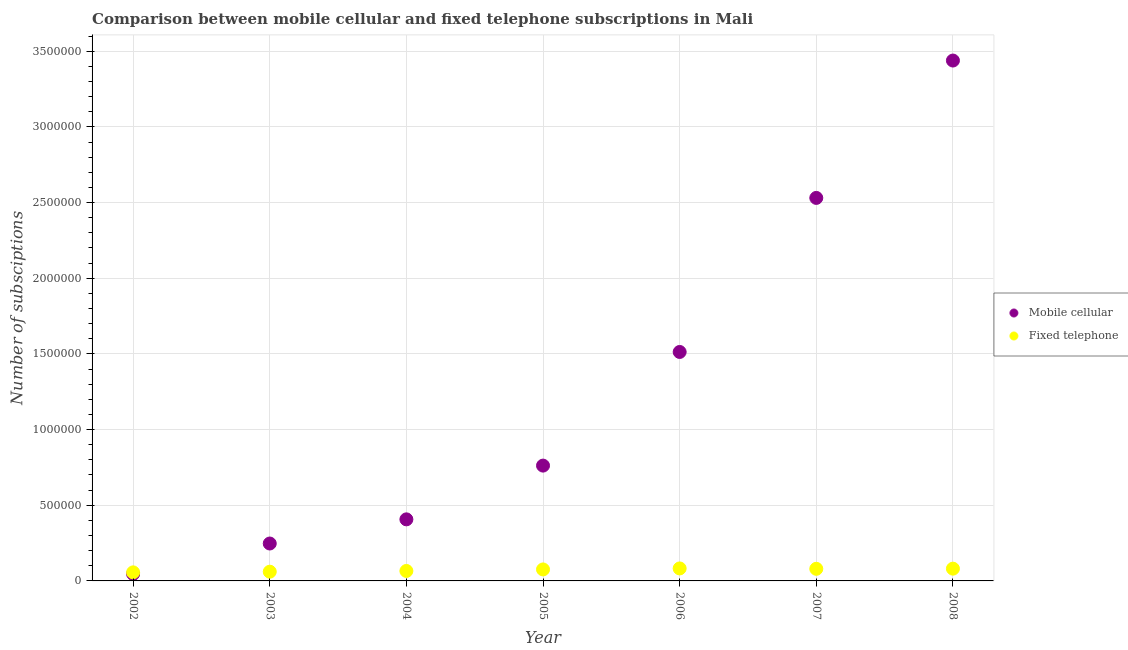How many different coloured dotlines are there?
Provide a succinct answer. 2. What is the number of mobile cellular subscriptions in 2006?
Give a very brief answer. 1.51e+06. Across all years, what is the maximum number of mobile cellular subscriptions?
Give a very brief answer. 3.44e+06. Across all years, what is the minimum number of fixed telephone subscriptions?
Give a very brief answer. 5.66e+04. In which year was the number of mobile cellular subscriptions maximum?
Offer a very short reply. 2008. In which year was the number of mobile cellular subscriptions minimum?
Give a very brief answer. 2002. What is the total number of fixed telephone subscriptions in the graph?
Keep it short and to the point. 5.03e+05. What is the difference between the number of fixed telephone subscriptions in 2004 and that in 2007?
Ensure brevity in your answer.  -1.42e+04. What is the difference between the number of fixed telephone subscriptions in 2003 and the number of mobile cellular subscriptions in 2007?
Offer a terse response. -2.47e+06. What is the average number of fixed telephone subscriptions per year?
Provide a succinct answer. 7.18e+04. In the year 2006, what is the difference between the number of fixed telephone subscriptions and number of mobile cellular subscriptions?
Your answer should be compact. -1.43e+06. What is the ratio of the number of mobile cellular subscriptions in 2004 to that in 2006?
Provide a short and direct response. 0.27. Is the difference between the number of fixed telephone subscriptions in 2005 and 2008 greater than the difference between the number of mobile cellular subscriptions in 2005 and 2008?
Provide a succinct answer. Yes. What is the difference between the highest and the second highest number of mobile cellular subscriptions?
Offer a terse response. 9.08e+05. What is the difference between the highest and the lowest number of mobile cellular subscriptions?
Keep it short and to the point. 3.39e+06. In how many years, is the number of mobile cellular subscriptions greater than the average number of mobile cellular subscriptions taken over all years?
Give a very brief answer. 3. Is the sum of the number of mobile cellular subscriptions in 2004 and 2008 greater than the maximum number of fixed telephone subscriptions across all years?
Ensure brevity in your answer.  Yes. Is the number of fixed telephone subscriptions strictly less than the number of mobile cellular subscriptions over the years?
Make the answer very short. No. How many dotlines are there?
Your answer should be very brief. 2. Are the values on the major ticks of Y-axis written in scientific E-notation?
Provide a short and direct response. No. How many legend labels are there?
Provide a short and direct response. 2. How are the legend labels stacked?
Offer a very short reply. Vertical. What is the title of the graph?
Ensure brevity in your answer.  Comparison between mobile cellular and fixed telephone subscriptions in Mali. What is the label or title of the Y-axis?
Keep it short and to the point. Number of subsciptions. What is the Number of subsciptions of Mobile cellular in 2002?
Provide a succinct answer. 4.60e+04. What is the Number of subsciptions of Fixed telephone in 2002?
Your answer should be compact. 5.66e+04. What is the Number of subsciptions of Mobile cellular in 2003?
Offer a very short reply. 2.47e+05. What is the Number of subsciptions in Fixed telephone in 2003?
Offer a very short reply. 6.09e+04. What is the Number of subsciptions of Mobile cellular in 2004?
Give a very brief answer. 4.07e+05. What is the Number of subsciptions in Fixed telephone in 2004?
Offer a very short reply. 6.58e+04. What is the Number of subsciptions of Mobile cellular in 2005?
Offer a terse response. 7.62e+05. What is the Number of subsciptions in Fixed telephone in 2005?
Your answer should be compact. 7.59e+04. What is the Number of subsciptions in Mobile cellular in 2006?
Make the answer very short. 1.51e+06. What is the Number of subsciptions in Fixed telephone in 2006?
Give a very brief answer. 8.25e+04. What is the Number of subsciptions of Mobile cellular in 2007?
Provide a short and direct response. 2.53e+06. What is the Number of subsciptions in Fixed telephone in 2007?
Your answer should be very brief. 8.00e+04. What is the Number of subsciptions of Mobile cellular in 2008?
Provide a short and direct response. 3.44e+06. What is the Number of subsciptions of Fixed telephone in 2008?
Provide a succinct answer. 8.11e+04. Across all years, what is the maximum Number of subsciptions of Mobile cellular?
Provide a short and direct response. 3.44e+06. Across all years, what is the maximum Number of subsciptions of Fixed telephone?
Offer a very short reply. 8.25e+04. Across all years, what is the minimum Number of subsciptions in Mobile cellular?
Provide a succinct answer. 4.60e+04. Across all years, what is the minimum Number of subsciptions in Fixed telephone?
Offer a terse response. 5.66e+04. What is the total Number of subsciptions of Mobile cellular in the graph?
Offer a terse response. 8.94e+06. What is the total Number of subsciptions in Fixed telephone in the graph?
Your response must be concise. 5.03e+05. What is the difference between the Number of subsciptions in Mobile cellular in 2002 and that in 2003?
Give a very brief answer. -2.01e+05. What is the difference between the Number of subsciptions in Fixed telephone in 2002 and that in 2003?
Offer a very short reply. -4322. What is the difference between the Number of subsciptions in Mobile cellular in 2002 and that in 2004?
Keep it short and to the point. -3.61e+05. What is the difference between the Number of subsciptions in Fixed telephone in 2002 and that in 2004?
Offer a terse response. -9231. What is the difference between the Number of subsciptions of Mobile cellular in 2002 and that in 2005?
Keep it short and to the point. -7.16e+05. What is the difference between the Number of subsciptions in Fixed telephone in 2002 and that in 2005?
Provide a short and direct response. -1.93e+04. What is the difference between the Number of subsciptions of Mobile cellular in 2002 and that in 2006?
Offer a terse response. -1.47e+06. What is the difference between the Number of subsciptions of Fixed telephone in 2002 and that in 2006?
Provide a succinct answer. -2.59e+04. What is the difference between the Number of subsciptions of Mobile cellular in 2002 and that in 2007?
Your answer should be very brief. -2.48e+06. What is the difference between the Number of subsciptions in Fixed telephone in 2002 and that in 2007?
Provide a short and direct response. -2.34e+04. What is the difference between the Number of subsciptions of Mobile cellular in 2002 and that in 2008?
Your response must be concise. -3.39e+06. What is the difference between the Number of subsciptions of Fixed telephone in 2002 and that in 2008?
Provide a succinct answer. -2.45e+04. What is the difference between the Number of subsciptions of Mobile cellular in 2003 and that in 2004?
Your response must be concise. -1.60e+05. What is the difference between the Number of subsciptions in Fixed telephone in 2003 and that in 2004?
Offer a very short reply. -4909. What is the difference between the Number of subsciptions of Mobile cellular in 2003 and that in 2005?
Your answer should be compact. -5.15e+05. What is the difference between the Number of subsciptions in Fixed telephone in 2003 and that in 2005?
Provide a succinct answer. -1.50e+04. What is the difference between the Number of subsciptions of Mobile cellular in 2003 and that in 2006?
Give a very brief answer. -1.27e+06. What is the difference between the Number of subsciptions of Fixed telephone in 2003 and that in 2006?
Make the answer very short. -2.16e+04. What is the difference between the Number of subsciptions in Mobile cellular in 2003 and that in 2007?
Offer a very short reply. -2.28e+06. What is the difference between the Number of subsciptions in Fixed telephone in 2003 and that in 2007?
Offer a terse response. -1.91e+04. What is the difference between the Number of subsciptions of Mobile cellular in 2003 and that in 2008?
Provide a succinct answer. -3.19e+06. What is the difference between the Number of subsciptions in Fixed telephone in 2003 and that in 2008?
Ensure brevity in your answer.  -2.02e+04. What is the difference between the Number of subsciptions in Mobile cellular in 2004 and that in 2005?
Give a very brief answer. -3.55e+05. What is the difference between the Number of subsciptions in Fixed telephone in 2004 and that in 2005?
Your answer should be very brief. -1.01e+04. What is the difference between the Number of subsciptions of Mobile cellular in 2004 and that in 2006?
Give a very brief answer. -1.11e+06. What is the difference between the Number of subsciptions of Fixed telephone in 2004 and that in 2006?
Your response must be concise. -1.67e+04. What is the difference between the Number of subsciptions of Mobile cellular in 2004 and that in 2007?
Your response must be concise. -2.12e+06. What is the difference between the Number of subsciptions of Fixed telephone in 2004 and that in 2007?
Keep it short and to the point. -1.42e+04. What is the difference between the Number of subsciptions in Mobile cellular in 2004 and that in 2008?
Keep it short and to the point. -3.03e+06. What is the difference between the Number of subsciptions of Fixed telephone in 2004 and that in 2008?
Offer a very short reply. -1.52e+04. What is the difference between the Number of subsciptions in Mobile cellular in 2005 and that in 2006?
Your answer should be very brief. -7.51e+05. What is the difference between the Number of subsciptions of Fixed telephone in 2005 and that in 2006?
Provide a short and direct response. -6617. What is the difference between the Number of subsciptions of Mobile cellular in 2005 and that in 2007?
Provide a succinct answer. -1.77e+06. What is the difference between the Number of subsciptions in Fixed telephone in 2005 and that in 2007?
Your answer should be very brief. -4101. What is the difference between the Number of subsciptions of Mobile cellular in 2005 and that in 2008?
Your response must be concise. -2.68e+06. What is the difference between the Number of subsciptions of Fixed telephone in 2005 and that in 2008?
Your answer should be very brief. -5172. What is the difference between the Number of subsciptions of Mobile cellular in 2006 and that in 2007?
Your answer should be very brief. -1.02e+06. What is the difference between the Number of subsciptions of Fixed telephone in 2006 and that in 2007?
Offer a very short reply. 2516. What is the difference between the Number of subsciptions of Mobile cellular in 2006 and that in 2008?
Keep it short and to the point. -1.93e+06. What is the difference between the Number of subsciptions of Fixed telephone in 2006 and that in 2008?
Your answer should be very brief. 1445. What is the difference between the Number of subsciptions in Mobile cellular in 2007 and that in 2008?
Ensure brevity in your answer.  -9.08e+05. What is the difference between the Number of subsciptions of Fixed telephone in 2007 and that in 2008?
Provide a short and direct response. -1071. What is the difference between the Number of subsciptions of Mobile cellular in 2002 and the Number of subsciptions of Fixed telephone in 2003?
Give a very brief answer. -1.50e+04. What is the difference between the Number of subsciptions of Mobile cellular in 2002 and the Number of subsciptions of Fixed telephone in 2004?
Your response must be concise. -1.99e+04. What is the difference between the Number of subsciptions of Mobile cellular in 2002 and the Number of subsciptions of Fixed telephone in 2005?
Ensure brevity in your answer.  -2.99e+04. What is the difference between the Number of subsciptions in Mobile cellular in 2002 and the Number of subsciptions in Fixed telephone in 2006?
Give a very brief answer. -3.65e+04. What is the difference between the Number of subsciptions of Mobile cellular in 2002 and the Number of subsciptions of Fixed telephone in 2007?
Offer a very short reply. -3.40e+04. What is the difference between the Number of subsciptions in Mobile cellular in 2002 and the Number of subsciptions in Fixed telephone in 2008?
Your answer should be compact. -3.51e+04. What is the difference between the Number of subsciptions in Mobile cellular in 2003 and the Number of subsciptions in Fixed telephone in 2004?
Make the answer very short. 1.81e+05. What is the difference between the Number of subsciptions of Mobile cellular in 2003 and the Number of subsciptions of Fixed telephone in 2005?
Your answer should be compact. 1.71e+05. What is the difference between the Number of subsciptions of Mobile cellular in 2003 and the Number of subsciptions of Fixed telephone in 2006?
Provide a succinct answer. 1.65e+05. What is the difference between the Number of subsciptions in Mobile cellular in 2003 and the Number of subsciptions in Fixed telephone in 2007?
Give a very brief answer. 1.67e+05. What is the difference between the Number of subsciptions of Mobile cellular in 2003 and the Number of subsciptions of Fixed telephone in 2008?
Your response must be concise. 1.66e+05. What is the difference between the Number of subsciptions of Mobile cellular in 2004 and the Number of subsciptions of Fixed telephone in 2005?
Offer a very short reply. 3.31e+05. What is the difference between the Number of subsciptions in Mobile cellular in 2004 and the Number of subsciptions in Fixed telephone in 2006?
Keep it short and to the point. 3.24e+05. What is the difference between the Number of subsciptions of Mobile cellular in 2004 and the Number of subsciptions of Fixed telephone in 2007?
Provide a short and direct response. 3.27e+05. What is the difference between the Number of subsciptions in Mobile cellular in 2004 and the Number of subsciptions in Fixed telephone in 2008?
Offer a very short reply. 3.26e+05. What is the difference between the Number of subsciptions in Mobile cellular in 2005 and the Number of subsciptions in Fixed telephone in 2006?
Give a very brief answer. 6.79e+05. What is the difference between the Number of subsciptions of Mobile cellular in 2005 and the Number of subsciptions of Fixed telephone in 2007?
Offer a very short reply. 6.82e+05. What is the difference between the Number of subsciptions of Mobile cellular in 2005 and the Number of subsciptions of Fixed telephone in 2008?
Make the answer very short. 6.81e+05. What is the difference between the Number of subsciptions in Mobile cellular in 2006 and the Number of subsciptions in Fixed telephone in 2007?
Your answer should be compact. 1.43e+06. What is the difference between the Number of subsciptions of Mobile cellular in 2006 and the Number of subsciptions of Fixed telephone in 2008?
Offer a terse response. 1.43e+06. What is the difference between the Number of subsciptions in Mobile cellular in 2007 and the Number of subsciptions in Fixed telephone in 2008?
Give a very brief answer. 2.45e+06. What is the average Number of subsciptions of Mobile cellular per year?
Offer a very short reply. 1.28e+06. What is the average Number of subsciptions of Fixed telephone per year?
Offer a terse response. 7.18e+04. In the year 2002, what is the difference between the Number of subsciptions of Mobile cellular and Number of subsciptions of Fixed telephone?
Ensure brevity in your answer.  -1.06e+04. In the year 2003, what is the difference between the Number of subsciptions of Mobile cellular and Number of subsciptions of Fixed telephone?
Make the answer very short. 1.86e+05. In the year 2004, what is the difference between the Number of subsciptions in Mobile cellular and Number of subsciptions in Fixed telephone?
Offer a very short reply. 3.41e+05. In the year 2005, what is the difference between the Number of subsciptions in Mobile cellular and Number of subsciptions in Fixed telephone?
Offer a very short reply. 6.86e+05. In the year 2006, what is the difference between the Number of subsciptions in Mobile cellular and Number of subsciptions in Fixed telephone?
Keep it short and to the point. 1.43e+06. In the year 2007, what is the difference between the Number of subsciptions of Mobile cellular and Number of subsciptions of Fixed telephone?
Provide a succinct answer. 2.45e+06. In the year 2008, what is the difference between the Number of subsciptions of Mobile cellular and Number of subsciptions of Fixed telephone?
Provide a succinct answer. 3.36e+06. What is the ratio of the Number of subsciptions of Mobile cellular in 2002 to that in 2003?
Offer a terse response. 0.19. What is the ratio of the Number of subsciptions in Fixed telephone in 2002 to that in 2003?
Give a very brief answer. 0.93. What is the ratio of the Number of subsciptions in Mobile cellular in 2002 to that in 2004?
Provide a short and direct response. 0.11. What is the ratio of the Number of subsciptions of Fixed telephone in 2002 to that in 2004?
Your answer should be compact. 0.86. What is the ratio of the Number of subsciptions in Mobile cellular in 2002 to that in 2005?
Your answer should be compact. 0.06. What is the ratio of the Number of subsciptions in Fixed telephone in 2002 to that in 2005?
Your response must be concise. 0.75. What is the ratio of the Number of subsciptions of Mobile cellular in 2002 to that in 2006?
Ensure brevity in your answer.  0.03. What is the ratio of the Number of subsciptions of Fixed telephone in 2002 to that in 2006?
Make the answer very short. 0.69. What is the ratio of the Number of subsciptions in Mobile cellular in 2002 to that in 2007?
Keep it short and to the point. 0.02. What is the ratio of the Number of subsciptions of Fixed telephone in 2002 to that in 2007?
Offer a terse response. 0.71. What is the ratio of the Number of subsciptions of Mobile cellular in 2002 to that in 2008?
Offer a very short reply. 0.01. What is the ratio of the Number of subsciptions of Fixed telephone in 2002 to that in 2008?
Your answer should be very brief. 0.7. What is the ratio of the Number of subsciptions of Mobile cellular in 2003 to that in 2004?
Your response must be concise. 0.61. What is the ratio of the Number of subsciptions of Fixed telephone in 2003 to that in 2004?
Offer a terse response. 0.93. What is the ratio of the Number of subsciptions in Mobile cellular in 2003 to that in 2005?
Provide a short and direct response. 0.32. What is the ratio of the Number of subsciptions in Fixed telephone in 2003 to that in 2005?
Ensure brevity in your answer.  0.8. What is the ratio of the Number of subsciptions of Mobile cellular in 2003 to that in 2006?
Offer a terse response. 0.16. What is the ratio of the Number of subsciptions in Fixed telephone in 2003 to that in 2006?
Provide a short and direct response. 0.74. What is the ratio of the Number of subsciptions of Mobile cellular in 2003 to that in 2007?
Make the answer very short. 0.1. What is the ratio of the Number of subsciptions in Fixed telephone in 2003 to that in 2007?
Provide a short and direct response. 0.76. What is the ratio of the Number of subsciptions of Mobile cellular in 2003 to that in 2008?
Provide a succinct answer. 0.07. What is the ratio of the Number of subsciptions of Fixed telephone in 2003 to that in 2008?
Provide a short and direct response. 0.75. What is the ratio of the Number of subsciptions of Mobile cellular in 2004 to that in 2005?
Your answer should be very brief. 0.53. What is the ratio of the Number of subsciptions in Fixed telephone in 2004 to that in 2005?
Provide a short and direct response. 0.87. What is the ratio of the Number of subsciptions of Mobile cellular in 2004 to that in 2006?
Ensure brevity in your answer.  0.27. What is the ratio of the Number of subsciptions in Fixed telephone in 2004 to that in 2006?
Offer a terse response. 0.8. What is the ratio of the Number of subsciptions of Mobile cellular in 2004 to that in 2007?
Keep it short and to the point. 0.16. What is the ratio of the Number of subsciptions in Fixed telephone in 2004 to that in 2007?
Your response must be concise. 0.82. What is the ratio of the Number of subsciptions of Mobile cellular in 2004 to that in 2008?
Provide a succinct answer. 0.12. What is the ratio of the Number of subsciptions of Fixed telephone in 2004 to that in 2008?
Keep it short and to the point. 0.81. What is the ratio of the Number of subsciptions in Mobile cellular in 2005 to that in 2006?
Offer a very short reply. 0.5. What is the ratio of the Number of subsciptions in Fixed telephone in 2005 to that in 2006?
Make the answer very short. 0.92. What is the ratio of the Number of subsciptions of Mobile cellular in 2005 to that in 2007?
Ensure brevity in your answer.  0.3. What is the ratio of the Number of subsciptions of Fixed telephone in 2005 to that in 2007?
Provide a short and direct response. 0.95. What is the ratio of the Number of subsciptions in Mobile cellular in 2005 to that in 2008?
Your response must be concise. 0.22. What is the ratio of the Number of subsciptions in Fixed telephone in 2005 to that in 2008?
Ensure brevity in your answer.  0.94. What is the ratio of the Number of subsciptions of Mobile cellular in 2006 to that in 2007?
Your response must be concise. 0.6. What is the ratio of the Number of subsciptions in Fixed telephone in 2006 to that in 2007?
Your answer should be compact. 1.03. What is the ratio of the Number of subsciptions of Mobile cellular in 2006 to that in 2008?
Your answer should be compact. 0.44. What is the ratio of the Number of subsciptions in Fixed telephone in 2006 to that in 2008?
Your answer should be very brief. 1.02. What is the ratio of the Number of subsciptions in Mobile cellular in 2007 to that in 2008?
Your answer should be compact. 0.74. What is the ratio of the Number of subsciptions of Fixed telephone in 2007 to that in 2008?
Ensure brevity in your answer.  0.99. What is the difference between the highest and the second highest Number of subsciptions of Mobile cellular?
Your answer should be very brief. 9.08e+05. What is the difference between the highest and the second highest Number of subsciptions in Fixed telephone?
Give a very brief answer. 1445. What is the difference between the highest and the lowest Number of subsciptions in Mobile cellular?
Your answer should be very brief. 3.39e+06. What is the difference between the highest and the lowest Number of subsciptions of Fixed telephone?
Your answer should be very brief. 2.59e+04. 